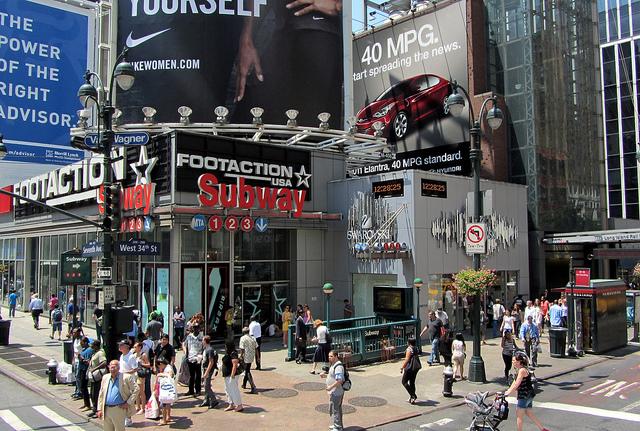Who stars in the movie advertised?
Quick response, please. No one. Is it raining?
Be succinct. No. What number of people are standing outside of the corner building?
Be succinct. 25. What is the name of the company emblem that is shown in the center billboard?
Quick response, please. Footaction. What color is the top of the girl pushing the carriage?
Give a very brief answer. Black. 